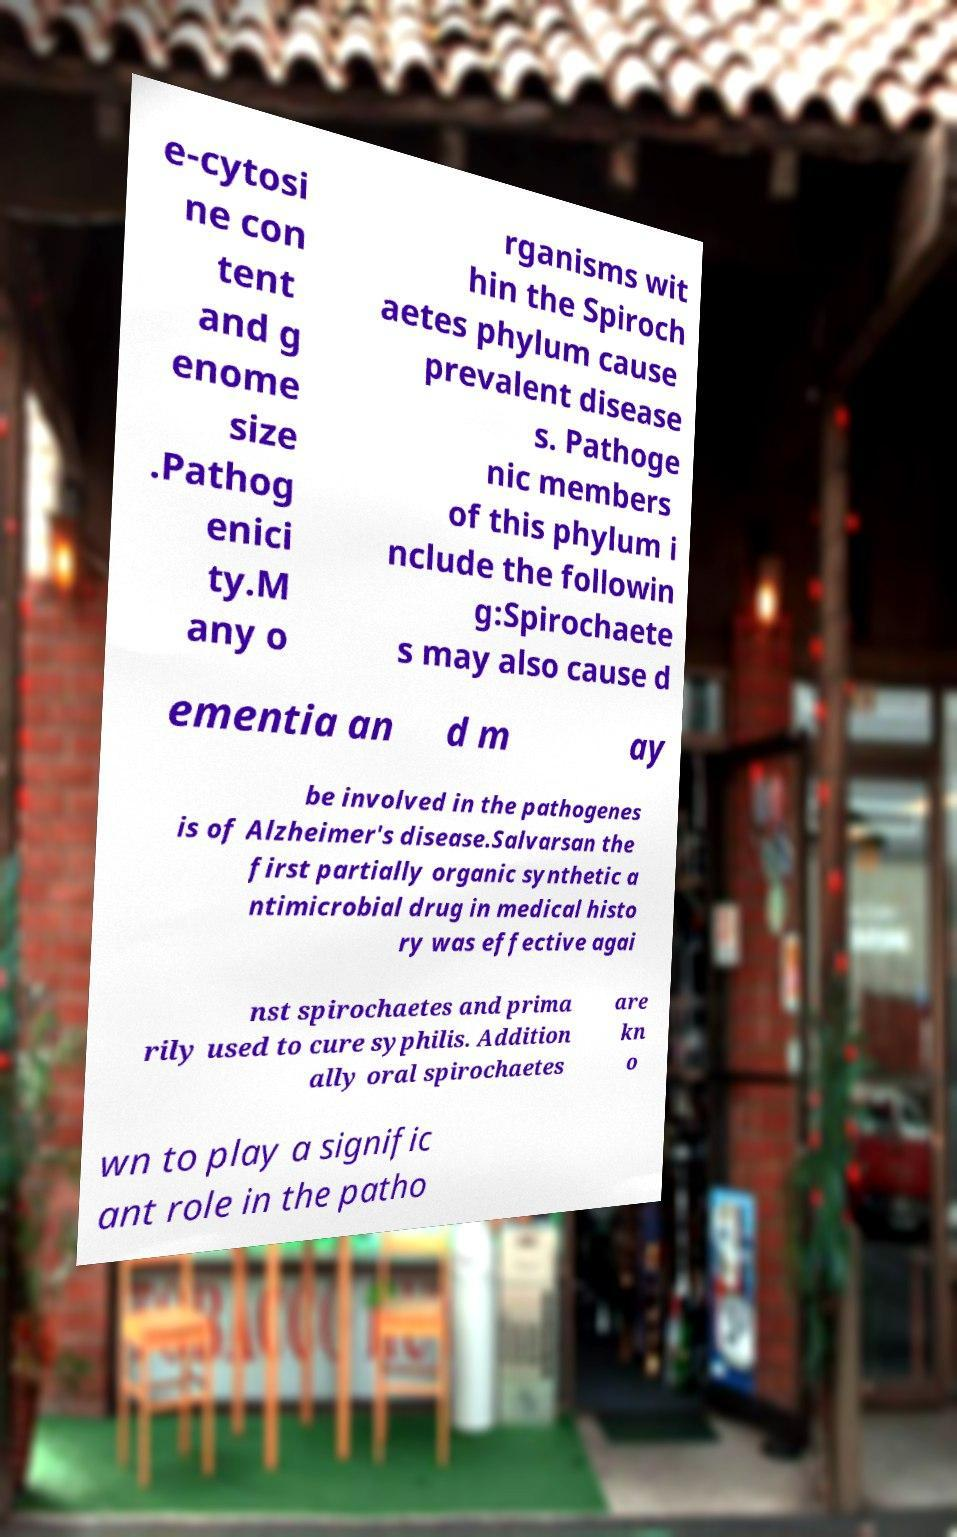Please read and relay the text visible in this image. What does it say? e-cytosi ne con tent and g enome size .Pathog enici ty.M any o rganisms wit hin the Spiroch aetes phylum cause prevalent disease s. Pathoge nic members of this phylum i nclude the followin g:Spirochaete s may also cause d ementia an d m ay be involved in the pathogenes is of Alzheimer's disease.Salvarsan the first partially organic synthetic a ntimicrobial drug in medical histo ry was effective agai nst spirochaetes and prima rily used to cure syphilis. Addition ally oral spirochaetes are kn o wn to play a signific ant role in the patho 